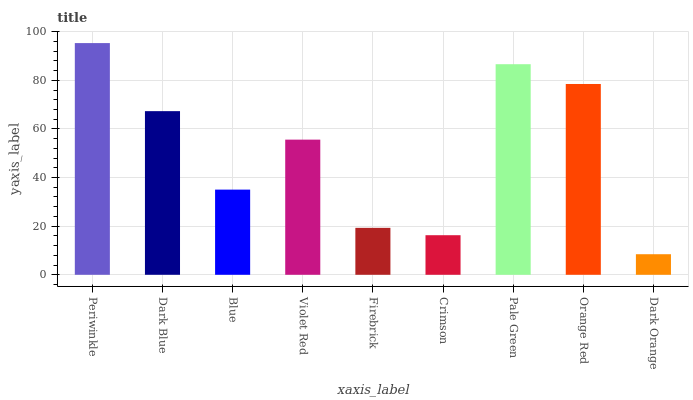Is Dark Orange the minimum?
Answer yes or no. Yes. Is Periwinkle the maximum?
Answer yes or no. Yes. Is Dark Blue the minimum?
Answer yes or no. No. Is Dark Blue the maximum?
Answer yes or no. No. Is Periwinkle greater than Dark Blue?
Answer yes or no. Yes. Is Dark Blue less than Periwinkle?
Answer yes or no. Yes. Is Dark Blue greater than Periwinkle?
Answer yes or no. No. Is Periwinkle less than Dark Blue?
Answer yes or no. No. Is Violet Red the high median?
Answer yes or no. Yes. Is Violet Red the low median?
Answer yes or no. Yes. Is Firebrick the high median?
Answer yes or no. No. Is Blue the low median?
Answer yes or no. No. 